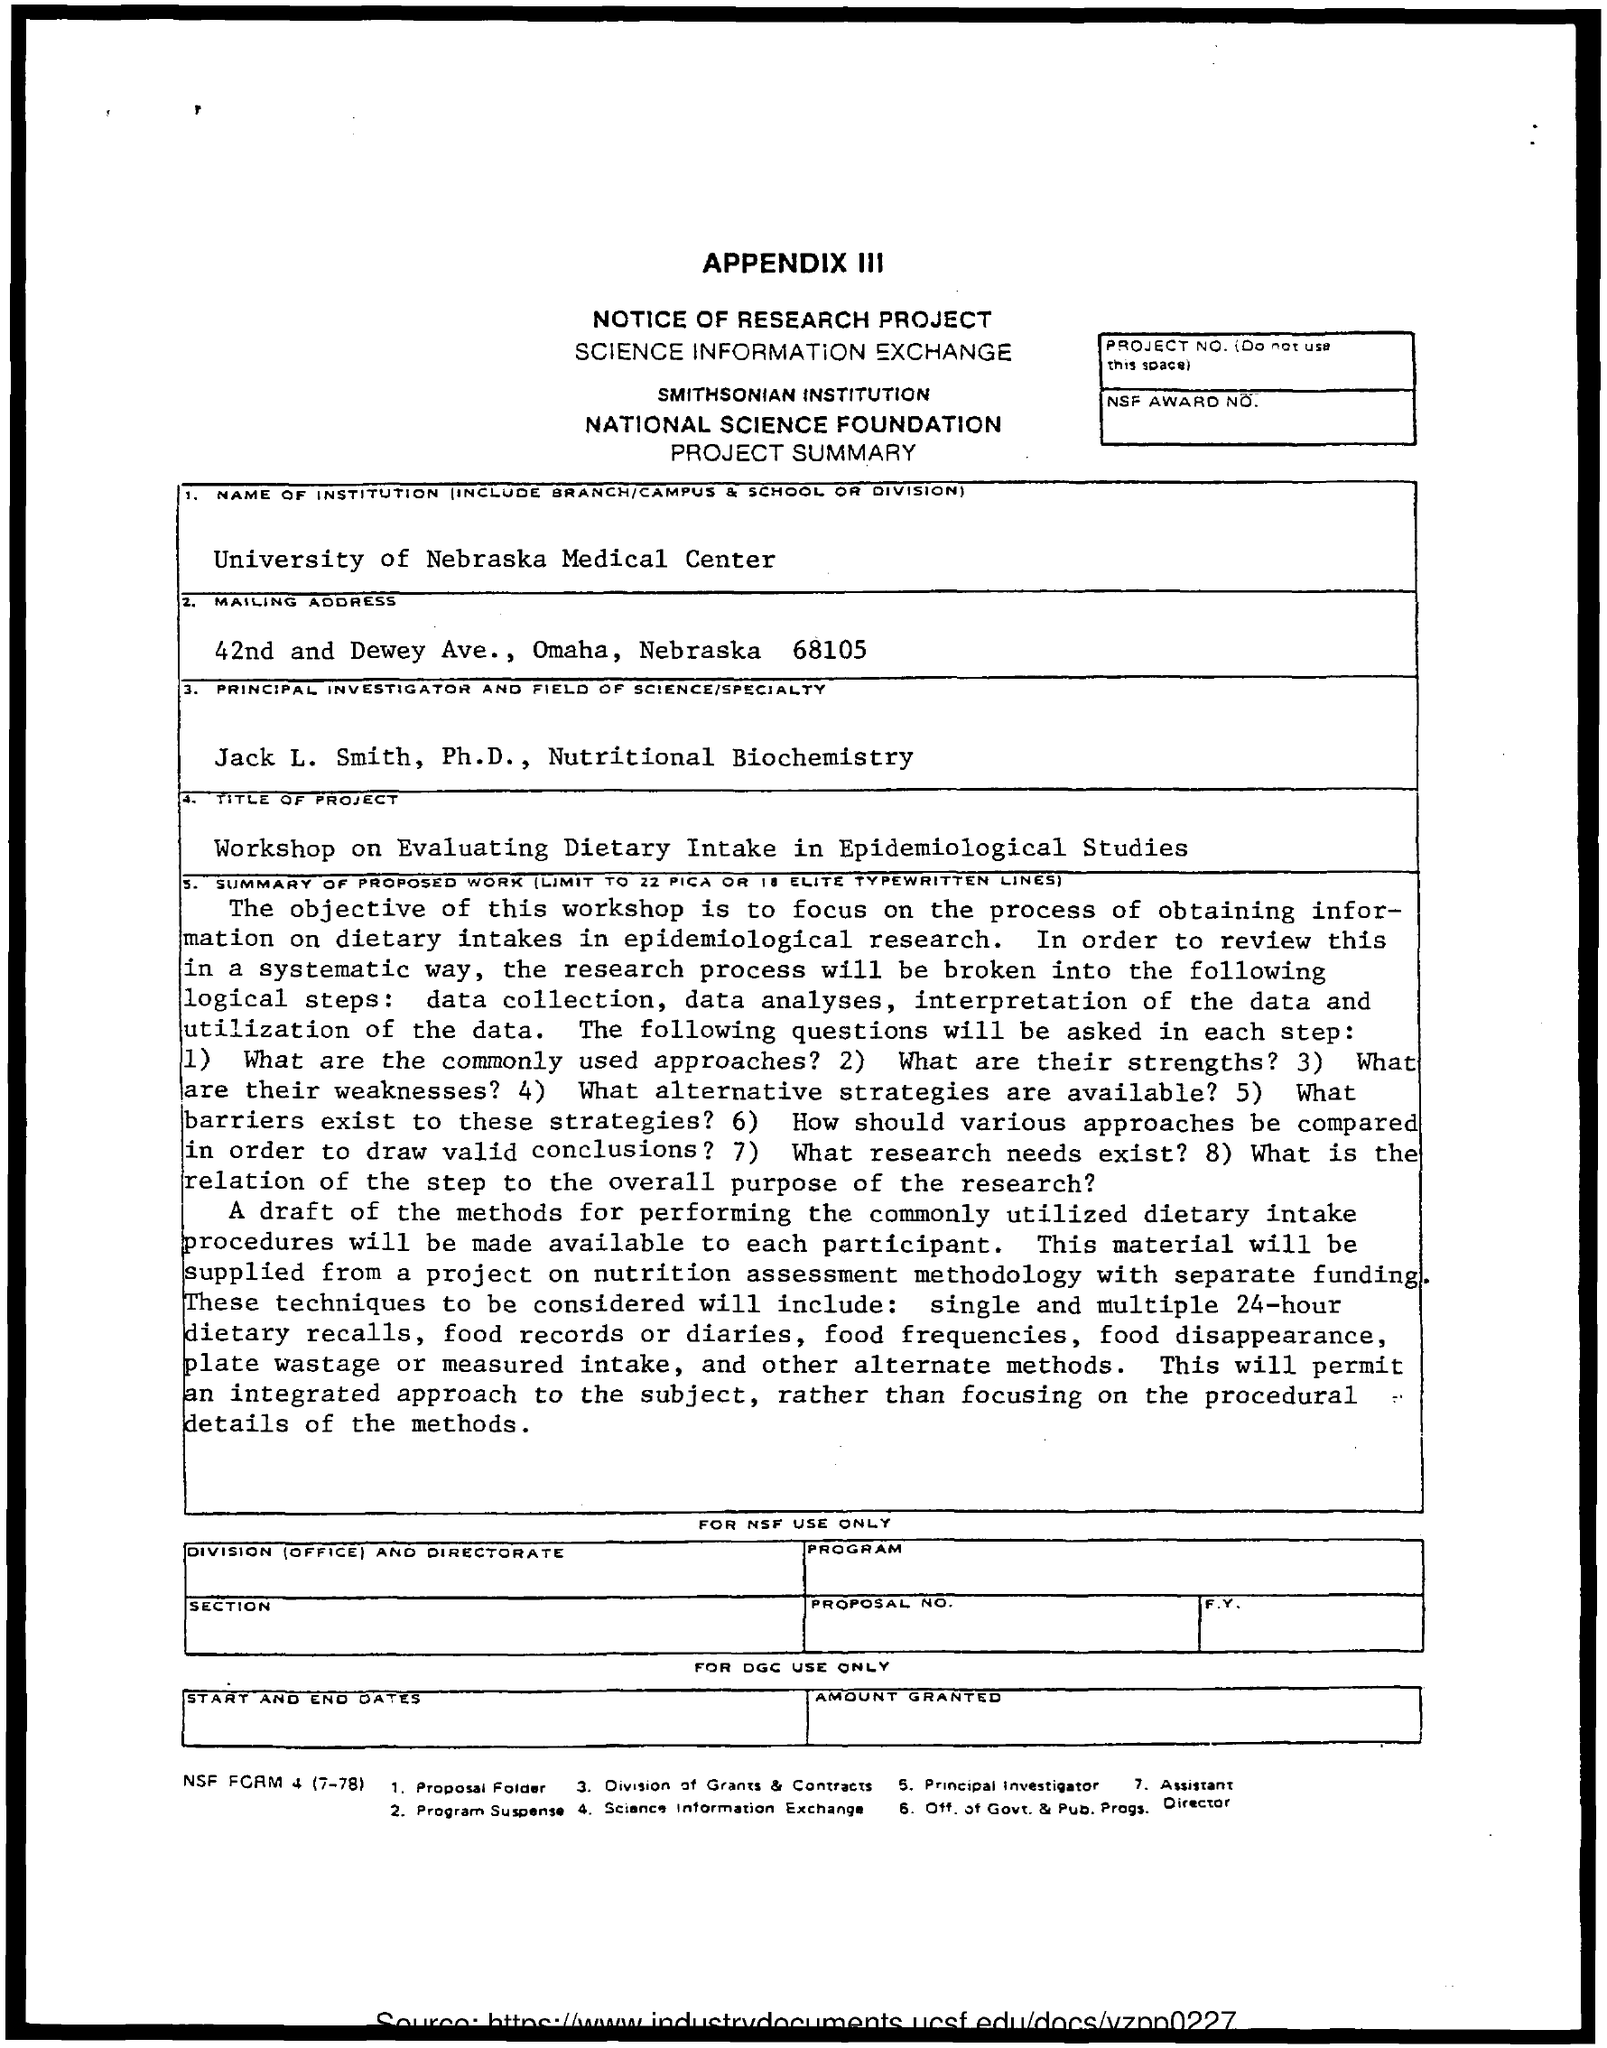What is the name of the institution?
Provide a succinct answer. University of Nebraska Medical Center. What is the name of the Principal Investigator?
Keep it short and to the point. Jack l. smith, ph.d. What is the title of the project?
Your answer should be very brief. Workshop on evaluating dietary intake in epidemiological studies. 